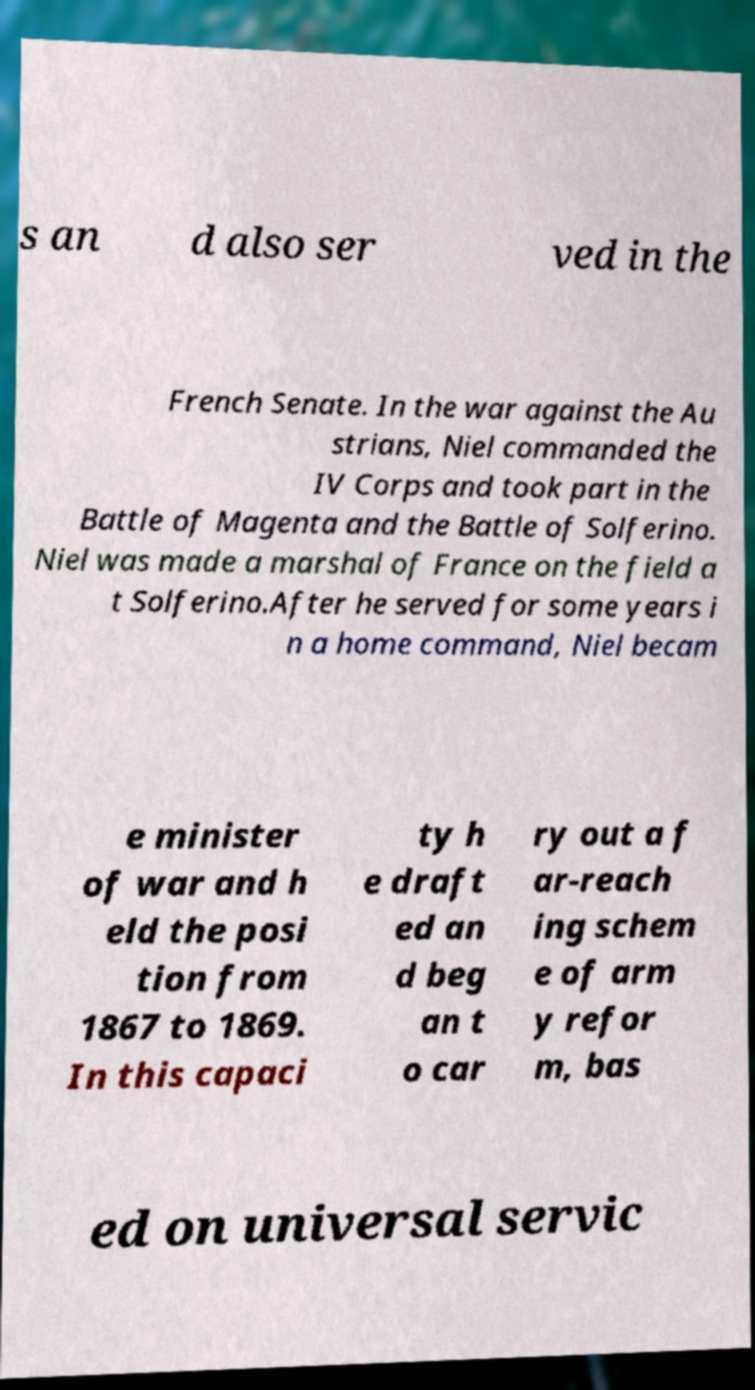Please read and relay the text visible in this image. What does it say? s an d also ser ved in the French Senate. In the war against the Au strians, Niel commanded the IV Corps and took part in the Battle of Magenta and the Battle of Solferino. Niel was made a marshal of France on the field a t Solferino.After he served for some years i n a home command, Niel becam e minister of war and h eld the posi tion from 1867 to 1869. In this capaci ty h e draft ed an d beg an t o car ry out a f ar-reach ing schem e of arm y refor m, bas ed on universal servic 